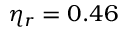Convert formula to latex. <formula><loc_0><loc_0><loc_500><loc_500>\eta _ { r } = 0 . 4 6</formula> 